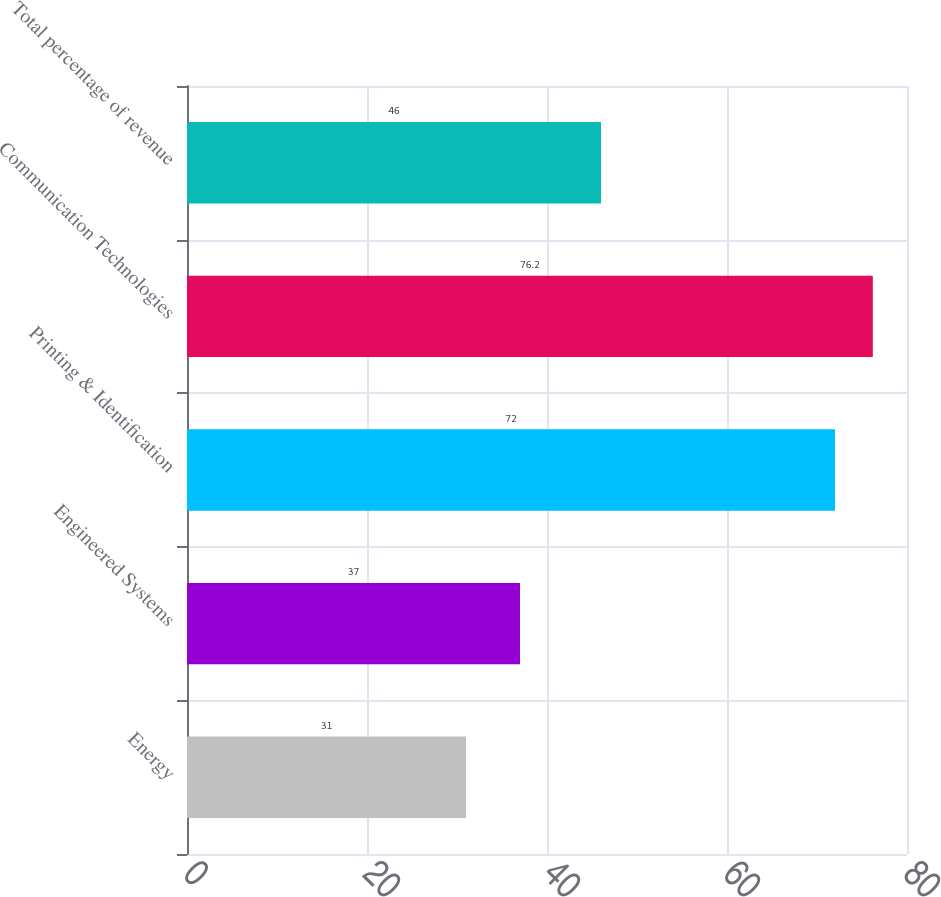<chart> <loc_0><loc_0><loc_500><loc_500><bar_chart><fcel>Energy<fcel>Engineered Systems<fcel>Printing & Identification<fcel>Communication Technologies<fcel>Total percentage of revenue<nl><fcel>31<fcel>37<fcel>72<fcel>76.2<fcel>46<nl></chart> 